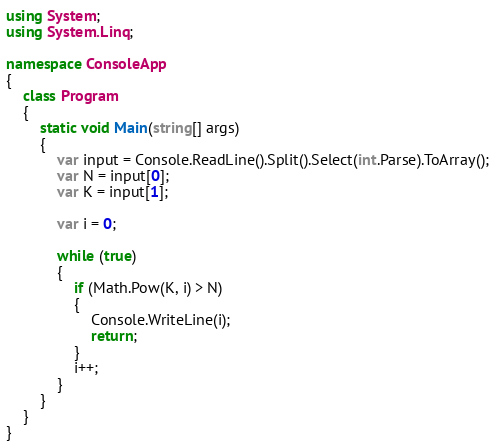Convert code to text. <code><loc_0><loc_0><loc_500><loc_500><_C#_>using System;
using System.Linq;

namespace ConsoleApp
{
    class Program
    {
        static void Main(string[] args)
        {
            var input = Console.ReadLine().Split().Select(int.Parse).ToArray();
            var N = input[0];
            var K = input[1];

            var i = 0;

            while (true)
            {
                if (Math.Pow(K, i) > N)
                {
                    Console.WriteLine(i);
                    return;
                }
                i++;
            }
        }
    }
}
</code> 